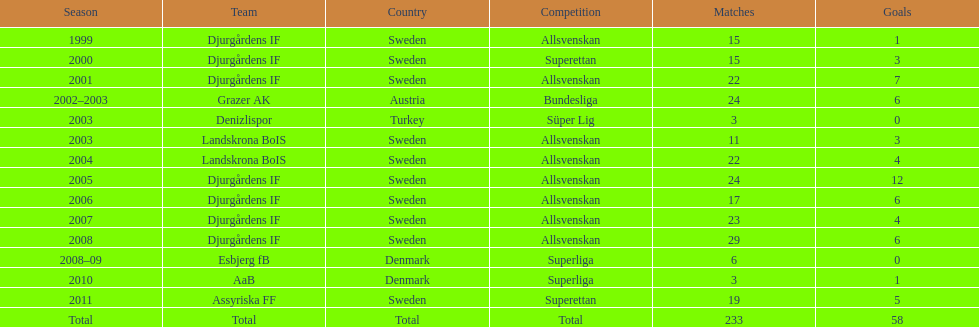Which team holds the record for the most goals scored? Djurgårdens IF. 